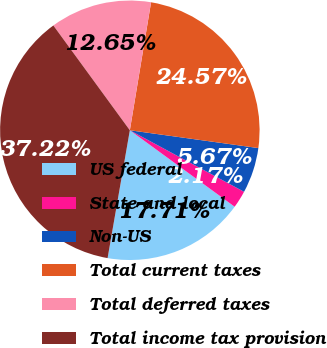<chart> <loc_0><loc_0><loc_500><loc_500><pie_chart><fcel>US federal<fcel>State and local<fcel>Non-US<fcel>Total current taxes<fcel>Total deferred taxes<fcel>Total income tax provision<nl><fcel>17.71%<fcel>2.17%<fcel>5.67%<fcel>24.57%<fcel>12.65%<fcel>37.22%<nl></chart> 